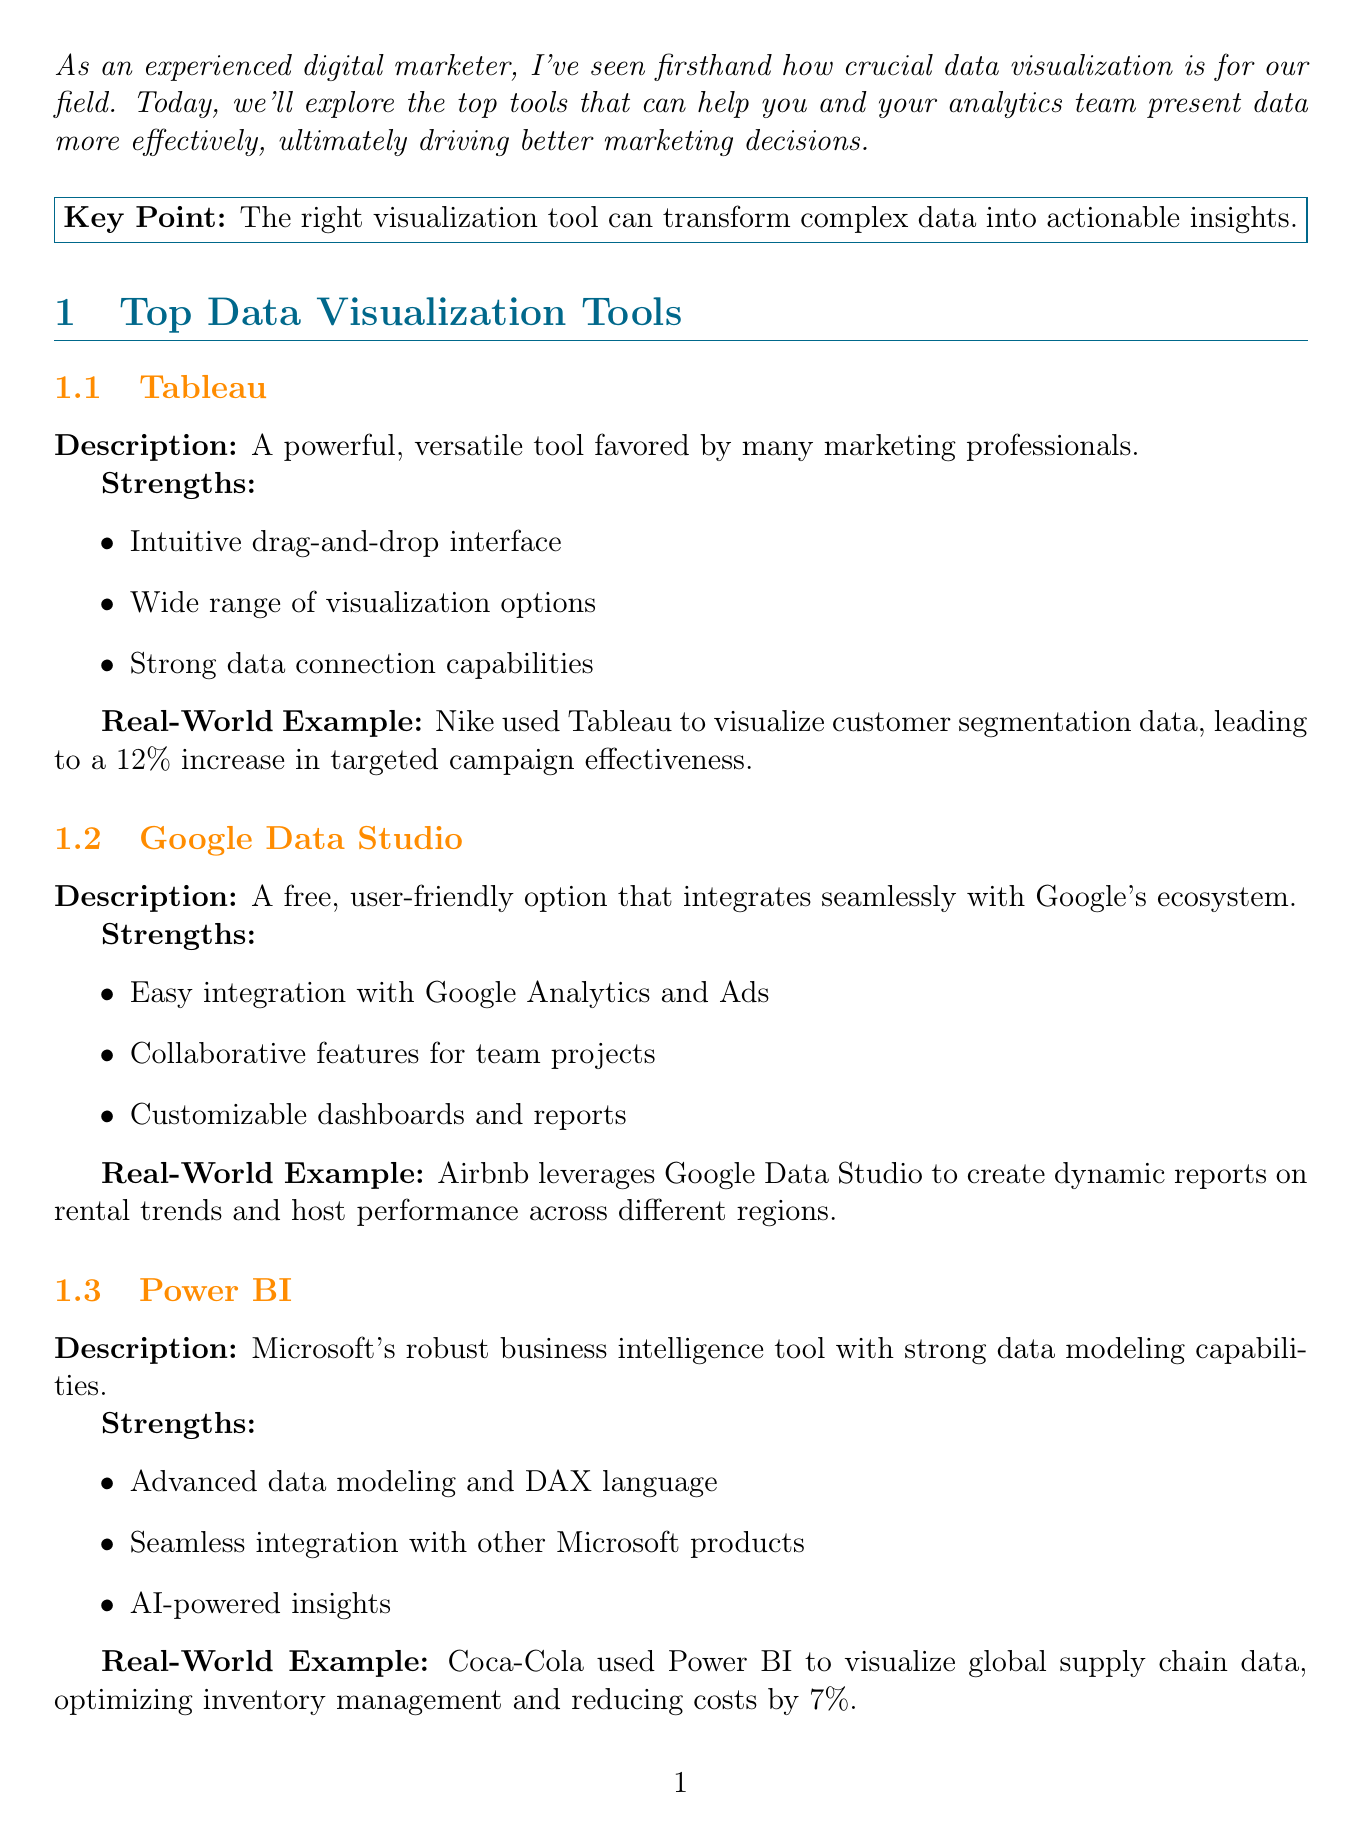What is the title of the newsletter? The title of the newsletter is stated at the beginning of the document.
Answer: Data Visualization Tools for Marketing Analytics: A Comprehensive Guide What percentage increase did Nike achieve using Tableau? The information about Nike's achievement using Tableau is provided in the real-world example section.
Answer: 12% Which tool is described as a free option? The description of the tools includes mentions of their cost, and Google Data Studio is highlighted as free.
Answer: Google Data Studio What is the main strength of Power BI? The strengths of Power BI are listed in the document, with a significant strength being highlighted.
Answer: Advanced data modeling and DAX language Which company used Google Data Studio for reports? A specific real-world example mentions the use of Google Data Studio by a well-known company.
Answer: Airbnb What is one future trend in data visualization mentioned? The document discusses future trends in data visualization, and one of the trends is specifically noted.
Answer: Increased use of AI for predictive visualizations What is the call to action at the end of the newsletter? The conclusion section of the document contains a call to action encouraging engagement from readers.
Answer: Which visualization tool are you most excited to try? What change did HubSpot implement in their marketing analytics? The case study section explains a significant change in HubSpot's approach to marketing analytics.
Answer: Switched from static Excel reports to interactive Tableau dashboards What tool has a medium ease of use according to the comparison table? The comparison table lists various tools and their ease of use ratings.
Answer: Tableau 